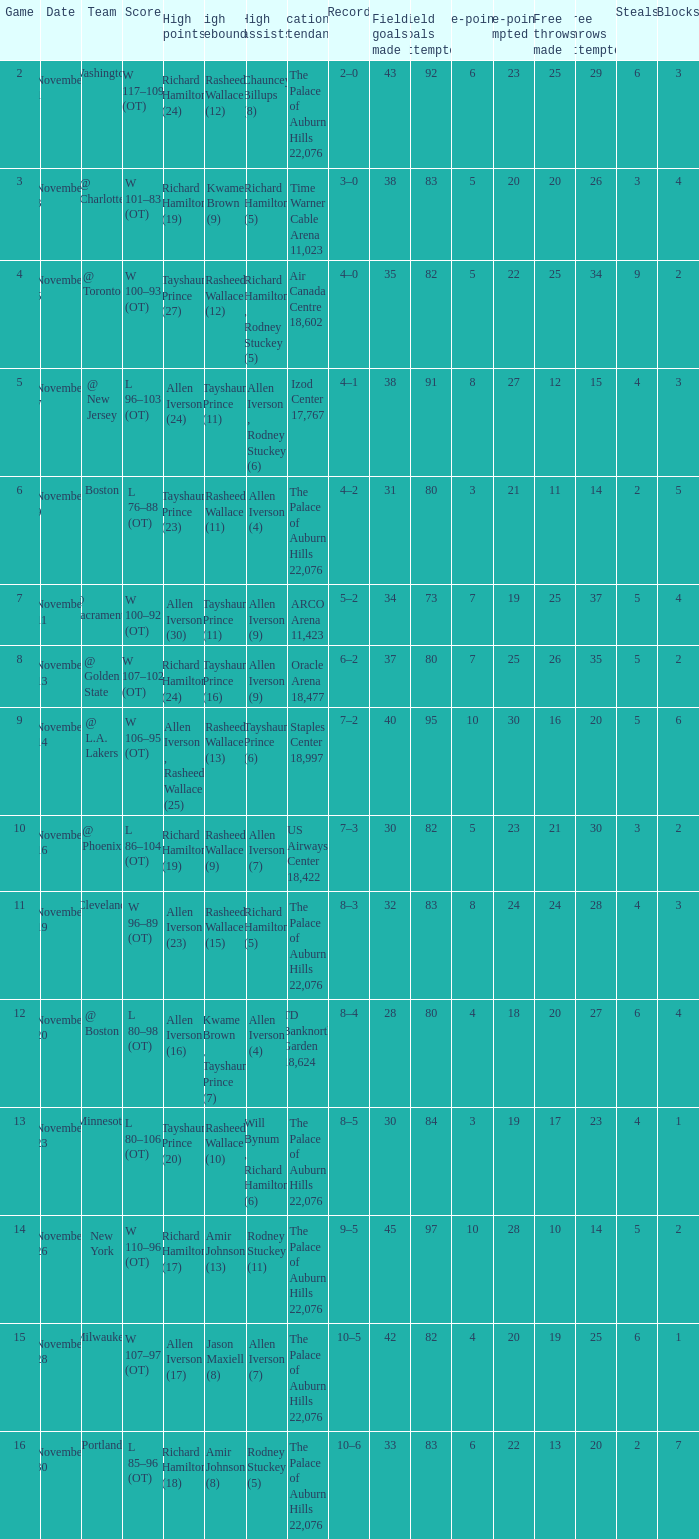What is the maximum score when the game is set to "5"? Allen Iverson (24). 